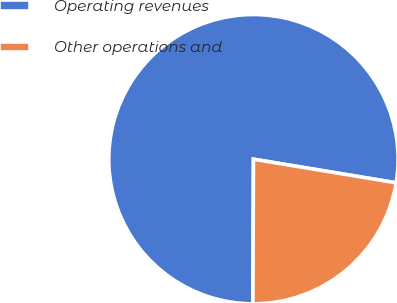Convert chart to OTSL. <chart><loc_0><loc_0><loc_500><loc_500><pie_chart><fcel>Operating revenues<fcel>Other operations and<nl><fcel>77.55%<fcel>22.45%<nl></chart> 